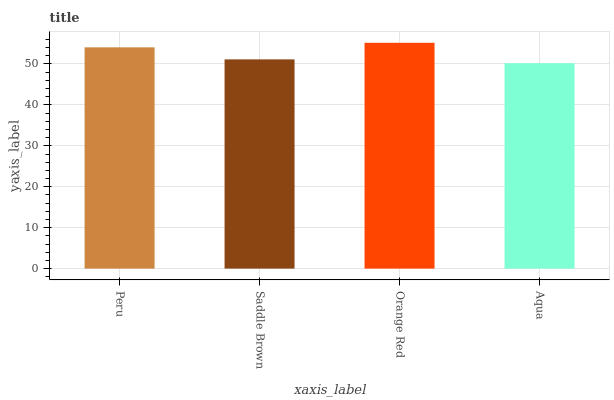Is Aqua the minimum?
Answer yes or no. Yes. Is Orange Red the maximum?
Answer yes or no. Yes. Is Saddle Brown the minimum?
Answer yes or no. No. Is Saddle Brown the maximum?
Answer yes or no. No. Is Peru greater than Saddle Brown?
Answer yes or no. Yes. Is Saddle Brown less than Peru?
Answer yes or no. Yes. Is Saddle Brown greater than Peru?
Answer yes or no. No. Is Peru less than Saddle Brown?
Answer yes or no. No. Is Peru the high median?
Answer yes or no. Yes. Is Saddle Brown the low median?
Answer yes or no. Yes. Is Orange Red the high median?
Answer yes or no. No. Is Orange Red the low median?
Answer yes or no. No. 